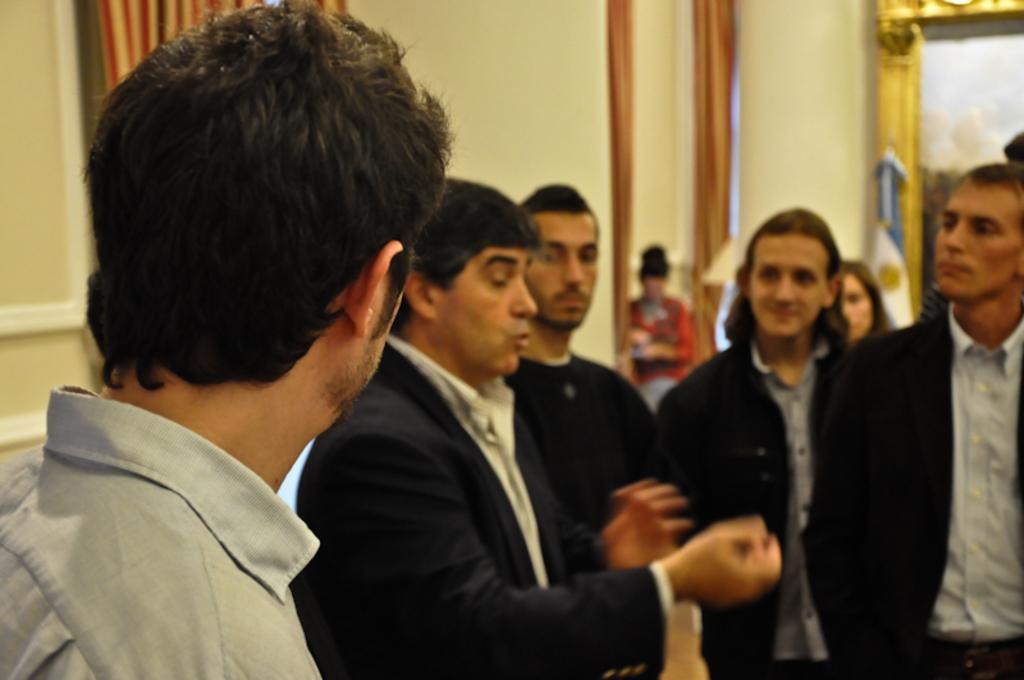Could you give a brief overview of what you see in this image? In the center of the image there are group of persons standing on the floor. At the left side of the image we can see a person standing. In the background there is a mirror, curtains, photo frame, person and a wall. 